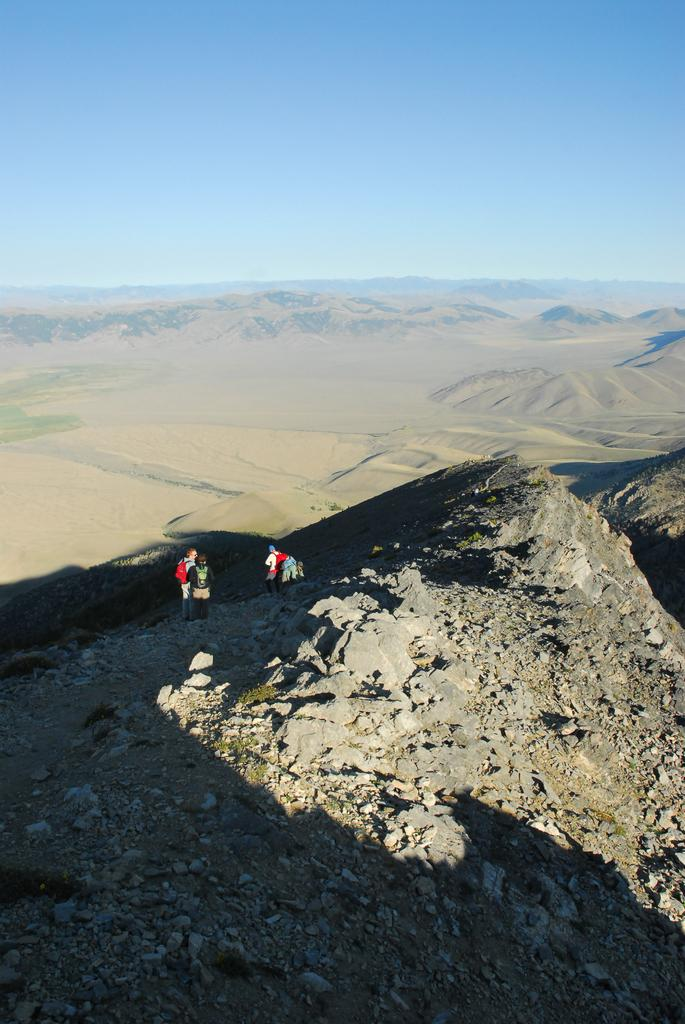What type of natural formation can be seen in the image? There are mountains in the image. How many people are present in the image? There are two persons standing in the image. What color is the sky in the image? The sky is blue at the top of the image. What type of trade is being conducted by the frog in the image? There is no frog present in the image, and therefore no trade can be observed. What type of voyage are the two persons embarking on in the image? The image does not provide any information about a voyage or the intentions of the two persons. 